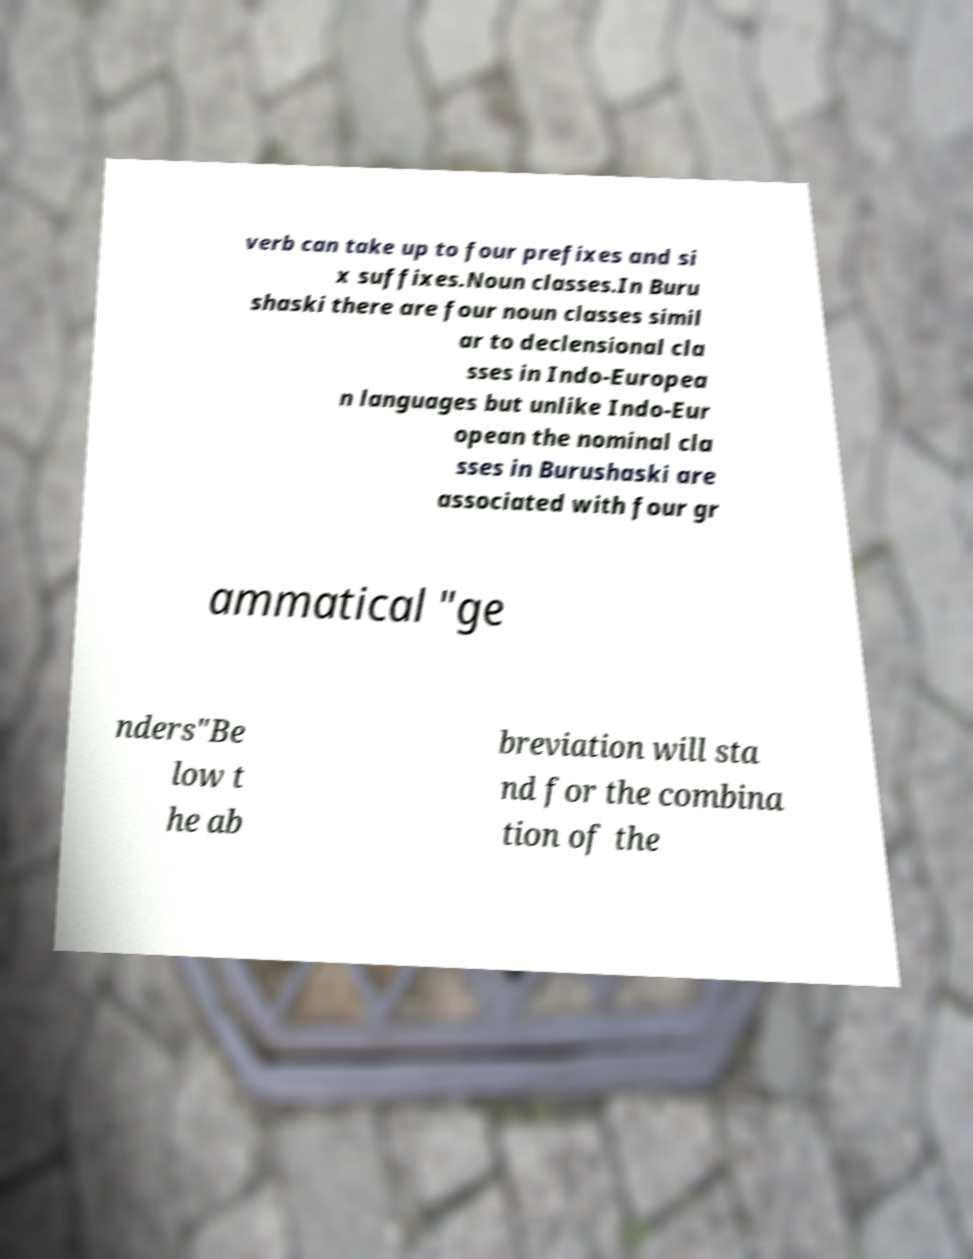Could you assist in decoding the text presented in this image and type it out clearly? verb can take up to four prefixes and si x suffixes.Noun classes.In Buru shaski there are four noun classes simil ar to declensional cla sses in Indo-Europea n languages but unlike Indo-Eur opean the nominal cla sses in Burushaski are associated with four gr ammatical "ge nders"Be low t he ab breviation will sta nd for the combina tion of the 